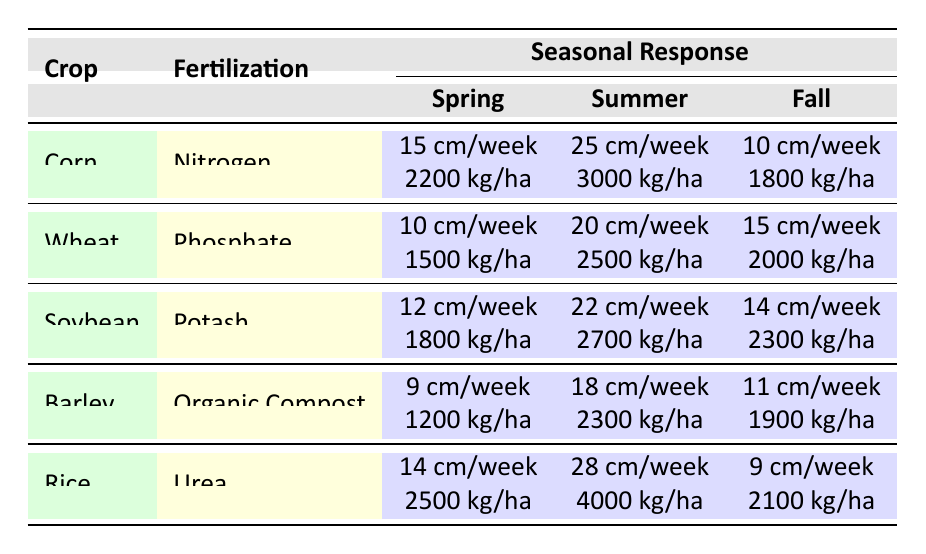What is the growth rate of Corn in Summer? The table shows that for Corn, the growth rate in Summer is listed under the SummerResponse section. According to the data, it is 25 cm/week.
Answer: 25 cm/week What is the yield of Soybean in Fall? To find the yield of Soybean in Fall, we look under the FallResponse section for Soybean. The table indicates the yield is 2300 kg/ha.
Answer: 2300 kg/ha True or False: The Spring yield of Wheat is higher than the Spring yield of Barley. To determine this, we check the Spring responses for both crops. Wheat has a yield of 1500 kg/ha and Barley has a yield of 1200 kg/ha. Since 1500 is greater than 1200, the statement is true.
Answer: True What is the average growth rate of Rice across all seasons? We find the growth rates for Rice in Spring (14 cm/week), Summer (28 cm/week), and Fall (9 cm/week). To calculate the average, we first sum these values: 14 + 28 + 9 = 51 cm/week. There are 3 seasons, so the average is 51/3 = 17 cm/week.
Answer: 17 cm/week Which crop has the highest yield in Summer, and what is that yield? We compare the Summer yields for each crop. The yields are: Corn (3000 kg/ha), Wheat (2500 kg/ha), Soybean (2700 kg/ha), Barley (2300 kg/ha), and Rice (4000 kg/ha). Rice has the highest yield among these values. Its yield is 4000 kg/ha.
Answer: Rice, 4000 kg/ha What is the total yield of Barley across all seasons? To find the total yield of Barley, we sum its yield across Spring (1200 kg/ha), Summer (2300 kg/ha), and Fall (1900 kg/ha). The total is calculated as 1200 + 2300 + 1900 = 5400 kg/ha.
Answer: 5400 kg/ha True or False: The growth rate in Spring for Soybean is higher than that for Wheat. From the table, we see that Soybean's growth rate in Spring is 12 cm/week and Wheat's is 10 cm/week. Since 12 is greater than 10, the statement is true.
Answer: True What is the difference in growth rate between Summer and Fall for Corn? We look at Corn's growth rates: Summer is 25 cm/week and Fall is 10 cm/week. The difference is 25 - 10 = 15 cm/week.
Answer: 15 cm/week How does the Fall yield of Rice compare to that of Wheat? The Fall yield for Rice is 2100 kg/ha and for Wheat is 2000 kg/ha. Comparing these, Rice has a higher yield (2100 vs 2000), therefore, Rice's Fall yield is greater than Wheat's.
Answer: Rice is higher 